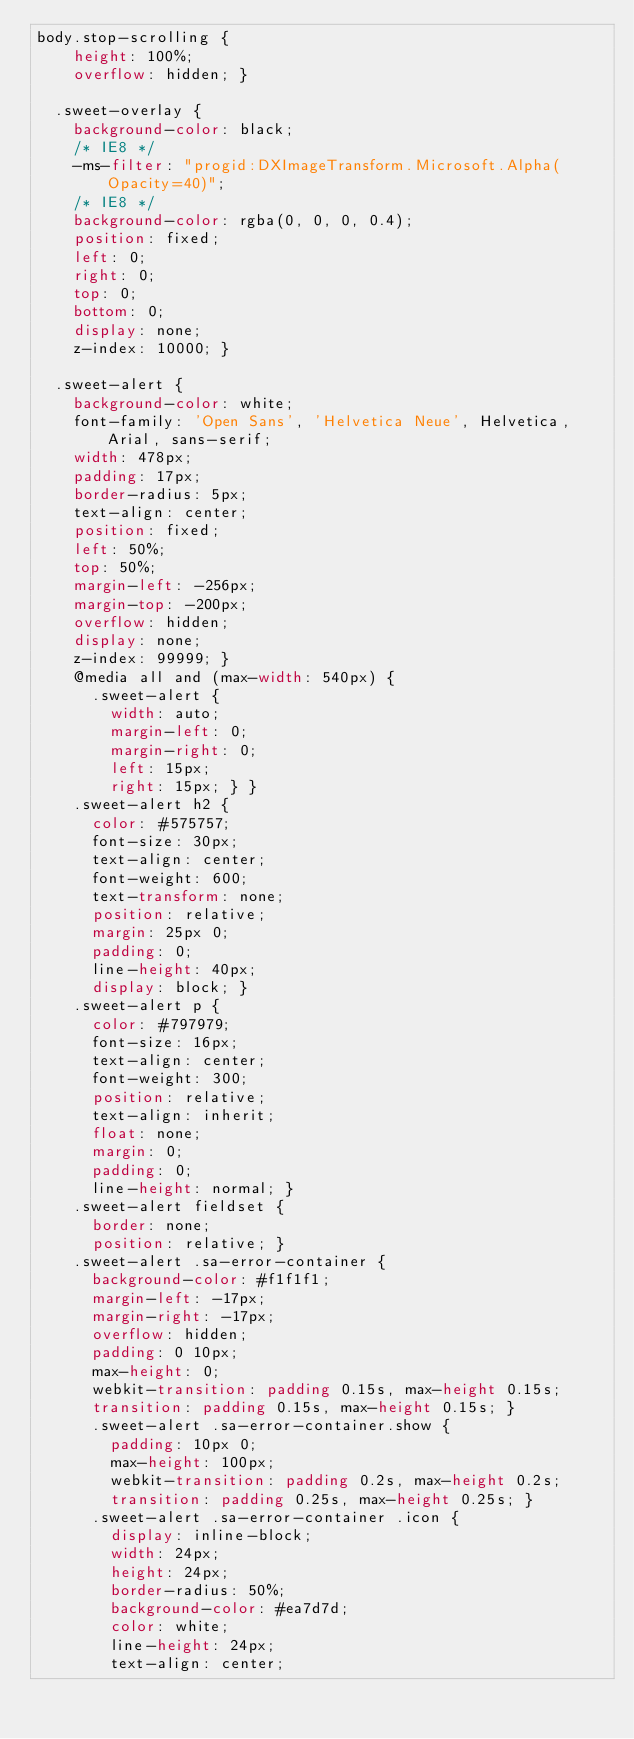Convert code to text. <code><loc_0><loc_0><loc_500><loc_500><_CSS_>body.stop-scrolling {
    height: 100%;
    overflow: hidden; }
  
  .sweet-overlay {
    background-color: black;
    /* IE8 */
    -ms-filter: "progid:DXImageTransform.Microsoft.Alpha(Opacity=40)";
    /* IE8 */
    background-color: rgba(0, 0, 0, 0.4);
    position: fixed;
    left: 0;
    right: 0;
    top: 0;
    bottom: 0;
    display: none;
    z-index: 10000; }
  
  .sweet-alert {
    background-color: white;
    font-family: 'Open Sans', 'Helvetica Neue', Helvetica, Arial, sans-serif;
    width: 478px;
    padding: 17px;
    border-radius: 5px;
    text-align: center;
    position: fixed;
    left: 50%;
    top: 50%;
    margin-left: -256px;
    margin-top: -200px;
    overflow: hidden;
    display: none;
    z-index: 99999; }
    @media all and (max-width: 540px) {
      .sweet-alert {
        width: auto;
        margin-left: 0;
        margin-right: 0;
        left: 15px;
        right: 15px; } }
    .sweet-alert h2 {
      color: #575757;
      font-size: 30px;
      text-align: center;
      font-weight: 600;
      text-transform: none;
      position: relative;
      margin: 25px 0;
      padding: 0;
      line-height: 40px;
      display: block; }
    .sweet-alert p {
      color: #797979;
      font-size: 16px;
      text-align: center;
      font-weight: 300;
      position: relative;
      text-align: inherit;
      float: none;
      margin: 0;
      padding: 0;
      line-height: normal; }
    .sweet-alert fieldset {
      border: none;
      position: relative; }
    .sweet-alert .sa-error-container {
      background-color: #f1f1f1;
      margin-left: -17px;
      margin-right: -17px;
      overflow: hidden;
      padding: 0 10px;
      max-height: 0;
      webkit-transition: padding 0.15s, max-height 0.15s;
      transition: padding 0.15s, max-height 0.15s; }
      .sweet-alert .sa-error-container.show {
        padding: 10px 0;
        max-height: 100px;
        webkit-transition: padding 0.2s, max-height 0.2s;
        transition: padding 0.25s, max-height 0.25s; }
      .sweet-alert .sa-error-container .icon {
        display: inline-block;
        width: 24px;
        height: 24px;
        border-radius: 50%;
        background-color: #ea7d7d;
        color: white;
        line-height: 24px;
        text-align: center;</code> 